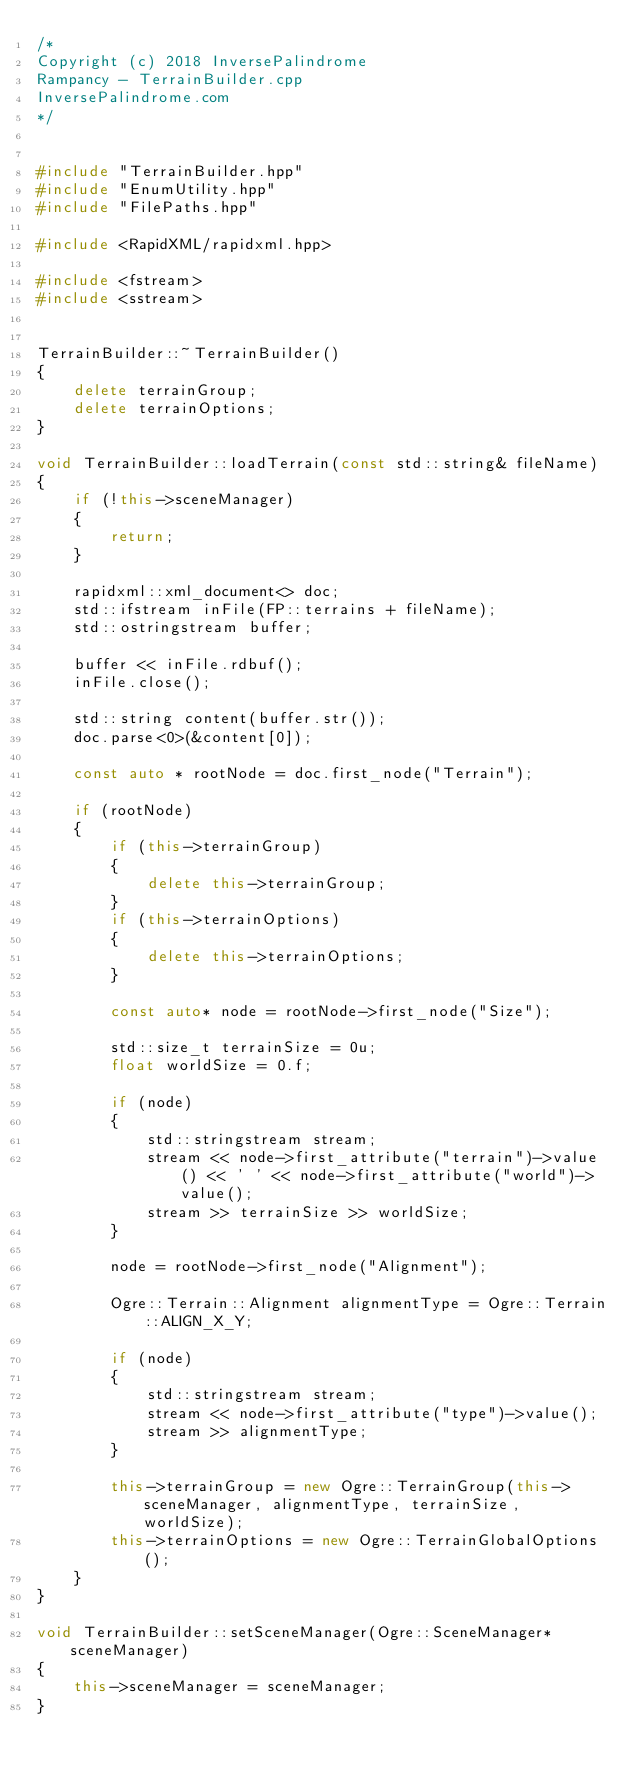Convert code to text. <code><loc_0><loc_0><loc_500><loc_500><_C++_>/*
Copyright (c) 2018 InversePalindrome
Rampancy - TerrainBuilder.cpp
InversePalindrome.com
*/


#include "TerrainBuilder.hpp"
#include "EnumUtility.hpp"
#include "FilePaths.hpp"

#include <RapidXML/rapidxml.hpp>

#include <fstream>
#include <sstream>


TerrainBuilder::~TerrainBuilder()
{
    delete terrainGroup;
    delete terrainOptions;
}

void TerrainBuilder::loadTerrain(const std::string& fileName)
{
    if (!this->sceneManager)
    {
        return;
    }

    rapidxml::xml_document<> doc;
    std::ifstream inFile(FP::terrains + fileName);
    std::ostringstream buffer;

    buffer << inFile.rdbuf();
    inFile.close();

    std::string content(buffer.str());
    doc.parse<0>(&content[0]);

    const auto * rootNode = doc.first_node("Terrain");

    if (rootNode)
    {
        if (this->terrainGroup)
        {
            delete this->terrainGroup;
        }
        if (this->terrainOptions)
        {
            delete this->terrainOptions;
        }

        const auto* node = rootNode->first_node("Size");

        std::size_t terrainSize = 0u;
        float worldSize = 0.f;

        if (node)
        {
            std::stringstream stream;
            stream << node->first_attribute("terrain")->value() << ' ' << node->first_attribute("world")->value();
            stream >> terrainSize >> worldSize;
        }

        node = rootNode->first_node("Alignment");

        Ogre::Terrain::Alignment alignmentType = Ogre::Terrain::ALIGN_X_Y;

        if (node)
        {
            std::stringstream stream;
            stream << node->first_attribute("type")->value();
            stream >> alignmentType;
        }

        this->terrainGroup = new Ogre::TerrainGroup(this->sceneManager, alignmentType, terrainSize, worldSize);
        this->terrainOptions = new Ogre::TerrainGlobalOptions();
    }
}

void TerrainBuilder::setSceneManager(Ogre::SceneManager* sceneManager)
{
    this->sceneManager = sceneManager;
}</code> 